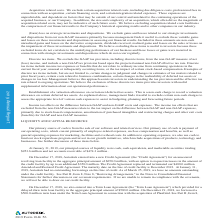According to Autodesk's financial document, What are purchase obligations? Based on the financial document, the answer is Purchase obligations are contractual obligations for purchase of goods or services and are defined as agreements that are enforceable and legally binding on Autodesk and that specify all significant terms, including: fixed or minimum quantities to be purchased; fixed, minimum, or variable price provisions; and the approximate timing of the transaction.. Also, Why are the purchase of supplies and other goods and services are not included in the table? Based on the financial document, the answer is We are not able to determine the aggregate amount of such purchase orders that represent contractual obligations, as purchase orders may represent authorizations to purchase rather than binding agreements. Our purchase orders are based on our current procurement or development needs and are fulfilled by our vendors within short time horizons. Also, What was the pension obligation for the fiscal year 2020? Based on the financial document, the answer is 2.4. Also, can you calculate: What is the amount of notes for fiscal years 2021-2024? Based on the calculation: 541.7+422.3 , the result is 964 (in millions). The key data points involved are: 422.3, 541.7. Also, can you calculate: What is the percentage of purchase obligations out of total obligations in 2020? Based on the calculation: (47.8/212.6), the result is 22.48 (percentage). The key data points involved are: 212.6, 47.8. Also, can you calculate: How much does contractual obligations from 2024 thereafter account for the total contractual obligations? Based on the calculation: 1,062.8/3,020.8 , the result is 35.18 (percentage). The key data points involved are: 1,062.8, 3,020.8. 